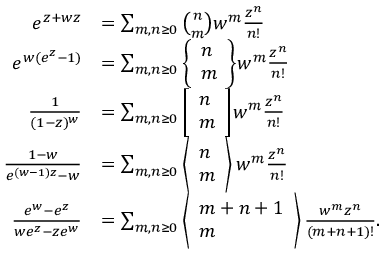<formula> <loc_0><loc_0><loc_500><loc_500>{ \begin{array} { r l } { e ^ { z + w z } } & { = \sum _ { m , n \geq 0 } { \binom { n } { m } } w ^ { m } { \frac { z ^ { n } } { n ! } } } \\ { e ^ { w ( e ^ { z } - 1 ) } } & { = \sum _ { m , n \geq 0 } { \left \{ \begin{array} { l } { n } \\ { m } \end{array} \right \} } w ^ { m } { \frac { z ^ { n } } { n ! } } } \\ { { \frac { 1 } { ( 1 - z ) ^ { w } } } } & { = \sum _ { m , n \geq 0 } { \left [ \begin{array} { l } { n } \\ { m } \end{array} \right ] } w ^ { m } { \frac { z ^ { n } } { n ! } } } \\ { { \frac { 1 - w } { e ^ { ( w - 1 ) z } - w } } } & { = \sum _ { m , n \geq 0 } \left \langle { \begin{array} { l } { n } \\ { m } \end{array} } \right \rangle w ^ { m } { \frac { z ^ { n } } { n ! } } } \\ { { \frac { e ^ { w } - e ^ { z } } { w e ^ { z } - z e ^ { w } } } } & { = \sum _ { m , n \geq 0 } \left \langle { \begin{array} { l } { m + n + 1 } \\ { m } \end{array} } \right \rangle { \frac { w ^ { m } z ^ { n } } { ( m + n + 1 ) ! } } . } \end{array} }</formula> 